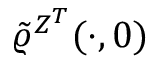Convert formula to latex. <formula><loc_0><loc_0><loc_500><loc_500>\tilde { \varrho } ^ { Z ^ { T } } ( \cdot , 0 )</formula> 